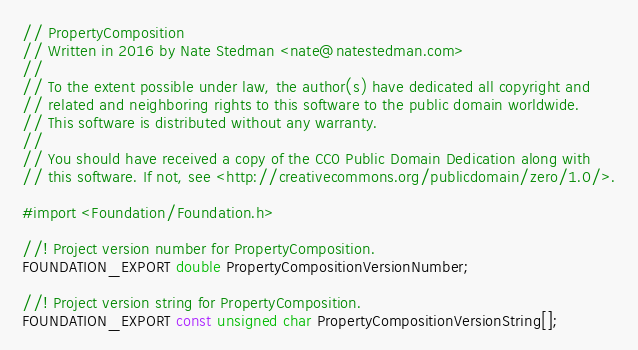Convert code to text. <code><loc_0><loc_0><loc_500><loc_500><_C_>// PropertyComposition
// Written in 2016 by Nate Stedman <nate@natestedman.com>
//
// To the extent possible under law, the author(s) have dedicated all copyright and
// related and neighboring rights to this software to the public domain worldwide.
// This software is distributed without any warranty.
//
// You should have received a copy of the CC0 Public Domain Dedication along with
// this software. If not, see <http://creativecommons.org/publicdomain/zero/1.0/>.

#import <Foundation/Foundation.h>

//! Project version number for PropertyComposition.
FOUNDATION_EXPORT double PropertyCompositionVersionNumber;

//! Project version string for PropertyComposition.
FOUNDATION_EXPORT const unsigned char PropertyCompositionVersionString[];
</code> 